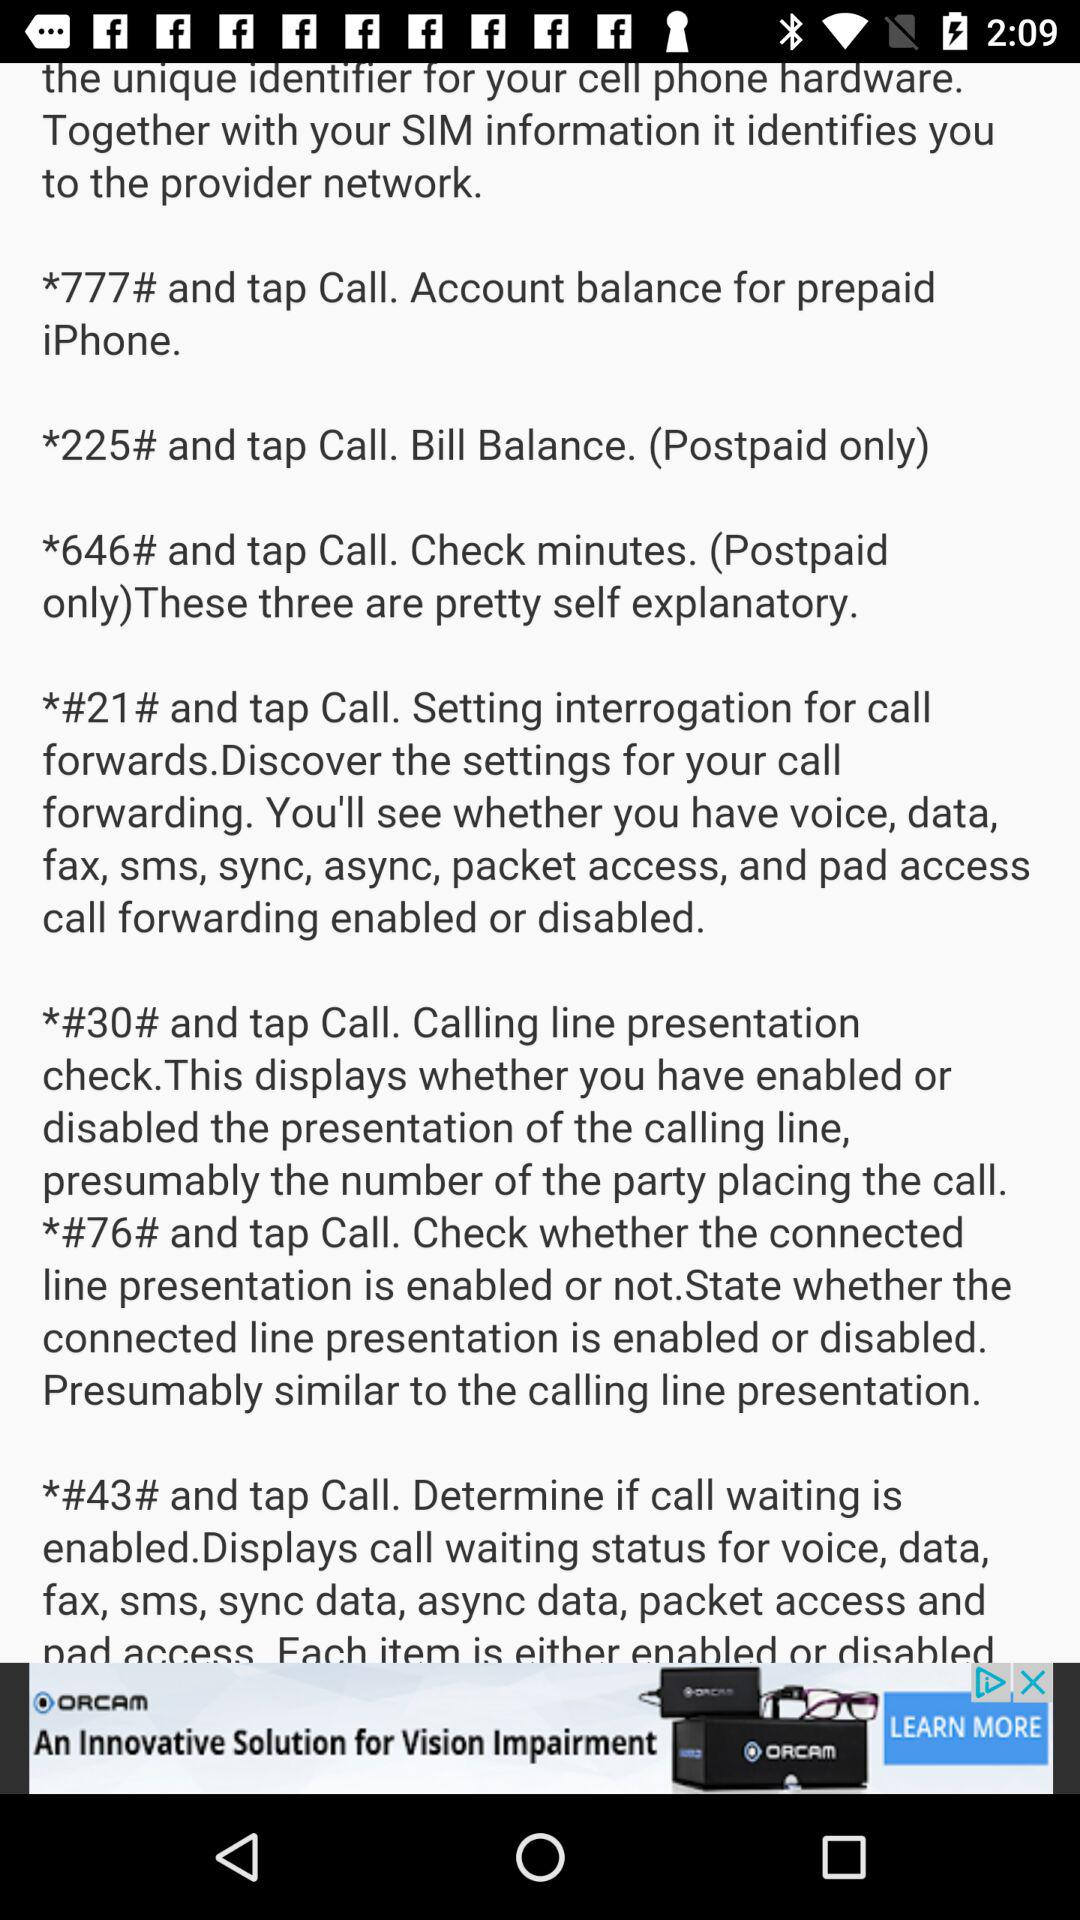What is the number for checking the account balance on the prepaid "iPhone"? The number for checking the account balance on the prepaid "iPhone" is *777#. 